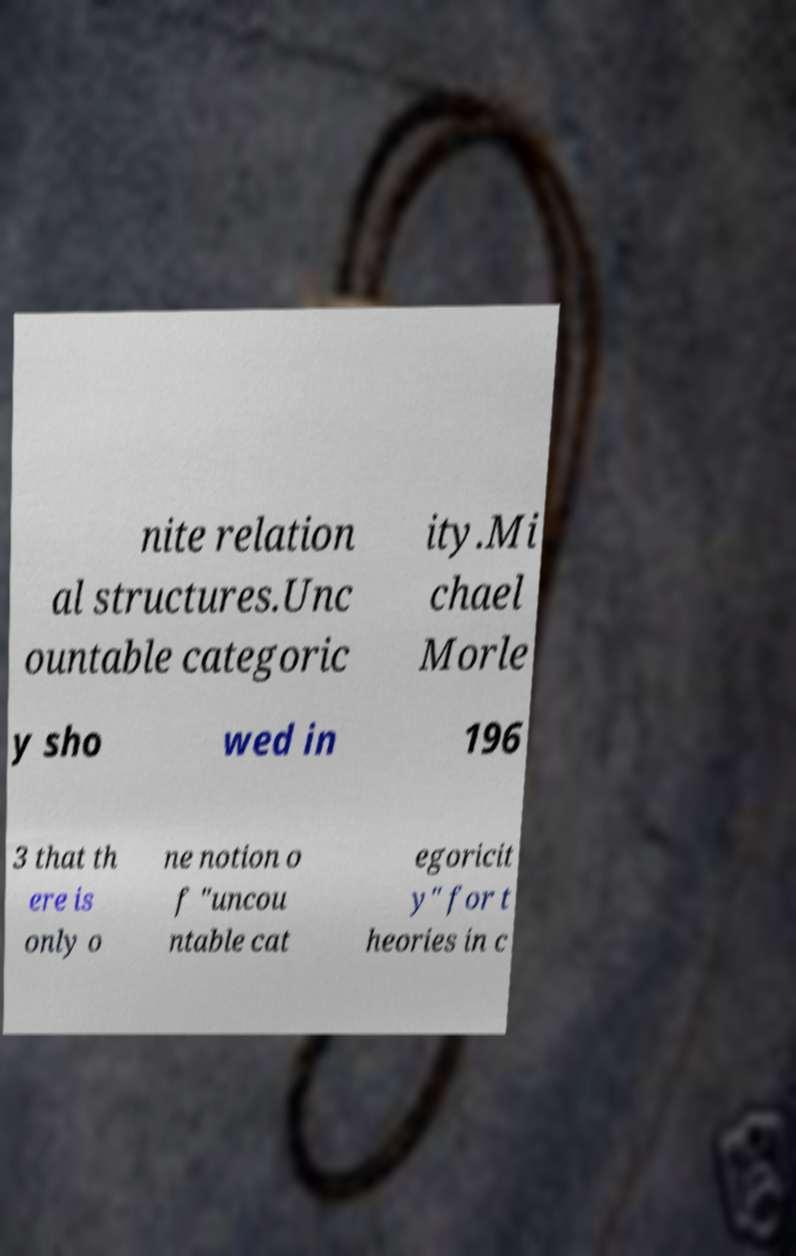Can you read and provide the text displayed in the image?This photo seems to have some interesting text. Can you extract and type it out for me? nite relation al structures.Unc ountable categoric ity.Mi chael Morle y sho wed in 196 3 that th ere is only o ne notion o f "uncou ntable cat egoricit y" for t heories in c 